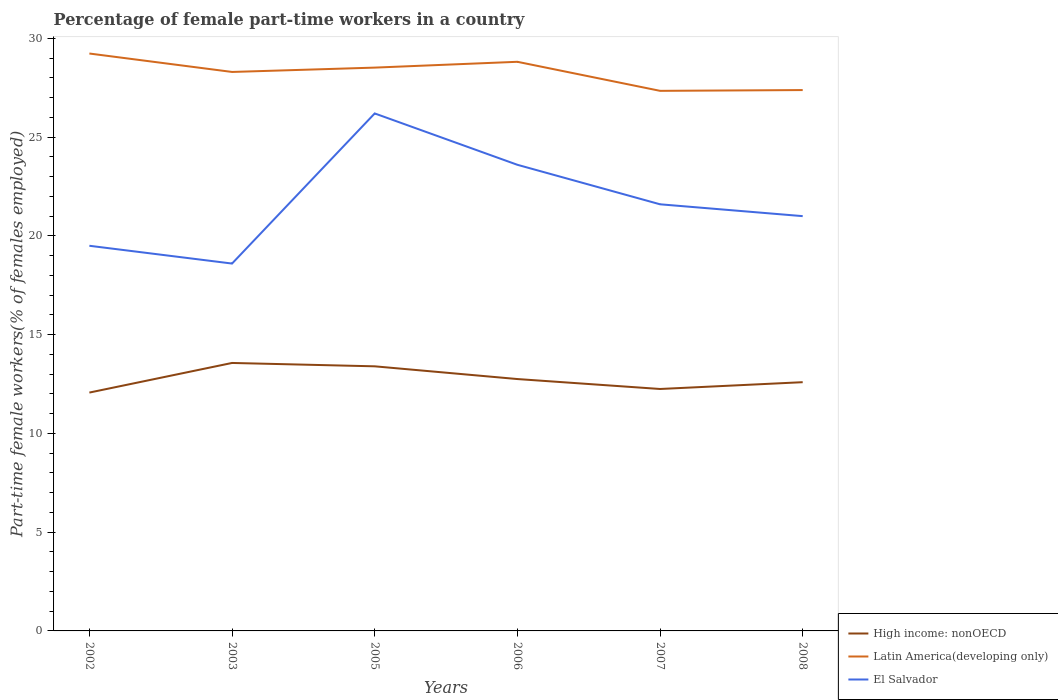How many different coloured lines are there?
Give a very brief answer. 3. Does the line corresponding to High income: nonOECD intersect with the line corresponding to Latin America(developing only)?
Give a very brief answer. No. Across all years, what is the maximum percentage of female part-time workers in High income: nonOECD?
Your response must be concise. 12.07. What is the total percentage of female part-time workers in High income: nonOECD in the graph?
Offer a terse response. 0.64. What is the difference between the highest and the second highest percentage of female part-time workers in High income: nonOECD?
Give a very brief answer. 1.5. How many years are there in the graph?
Give a very brief answer. 6. What is the difference between two consecutive major ticks on the Y-axis?
Your response must be concise. 5. Are the values on the major ticks of Y-axis written in scientific E-notation?
Provide a succinct answer. No. Where does the legend appear in the graph?
Provide a succinct answer. Bottom right. How many legend labels are there?
Your answer should be compact. 3. What is the title of the graph?
Your answer should be compact. Percentage of female part-time workers in a country. Does "Germany" appear as one of the legend labels in the graph?
Your answer should be compact. No. What is the label or title of the X-axis?
Your response must be concise. Years. What is the label or title of the Y-axis?
Your answer should be compact. Part-time female workers(% of females employed). What is the Part-time female workers(% of females employed) of High income: nonOECD in 2002?
Your response must be concise. 12.07. What is the Part-time female workers(% of females employed) in Latin America(developing only) in 2002?
Provide a succinct answer. 29.23. What is the Part-time female workers(% of females employed) in El Salvador in 2002?
Ensure brevity in your answer.  19.5. What is the Part-time female workers(% of females employed) of High income: nonOECD in 2003?
Ensure brevity in your answer.  13.57. What is the Part-time female workers(% of females employed) of Latin America(developing only) in 2003?
Keep it short and to the point. 28.3. What is the Part-time female workers(% of females employed) of El Salvador in 2003?
Your answer should be compact. 18.6. What is the Part-time female workers(% of females employed) of High income: nonOECD in 2005?
Offer a very short reply. 13.4. What is the Part-time female workers(% of females employed) of Latin America(developing only) in 2005?
Offer a terse response. 28.52. What is the Part-time female workers(% of females employed) in El Salvador in 2005?
Ensure brevity in your answer.  26.2. What is the Part-time female workers(% of females employed) in High income: nonOECD in 2006?
Your answer should be very brief. 12.75. What is the Part-time female workers(% of females employed) of Latin America(developing only) in 2006?
Offer a terse response. 28.81. What is the Part-time female workers(% of females employed) in El Salvador in 2006?
Provide a short and direct response. 23.6. What is the Part-time female workers(% of females employed) of High income: nonOECD in 2007?
Make the answer very short. 12.25. What is the Part-time female workers(% of females employed) in Latin America(developing only) in 2007?
Offer a very short reply. 27.34. What is the Part-time female workers(% of females employed) in El Salvador in 2007?
Give a very brief answer. 21.6. What is the Part-time female workers(% of females employed) in High income: nonOECD in 2008?
Provide a short and direct response. 12.59. What is the Part-time female workers(% of females employed) in Latin America(developing only) in 2008?
Your answer should be compact. 27.38. Across all years, what is the maximum Part-time female workers(% of females employed) in High income: nonOECD?
Your answer should be very brief. 13.57. Across all years, what is the maximum Part-time female workers(% of females employed) of Latin America(developing only)?
Ensure brevity in your answer.  29.23. Across all years, what is the maximum Part-time female workers(% of females employed) in El Salvador?
Your response must be concise. 26.2. Across all years, what is the minimum Part-time female workers(% of females employed) in High income: nonOECD?
Make the answer very short. 12.07. Across all years, what is the minimum Part-time female workers(% of females employed) of Latin America(developing only)?
Your answer should be compact. 27.34. Across all years, what is the minimum Part-time female workers(% of females employed) of El Salvador?
Your answer should be compact. 18.6. What is the total Part-time female workers(% of females employed) in High income: nonOECD in the graph?
Ensure brevity in your answer.  76.63. What is the total Part-time female workers(% of females employed) in Latin America(developing only) in the graph?
Your response must be concise. 169.6. What is the total Part-time female workers(% of females employed) in El Salvador in the graph?
Offer a terse response. 130.5. What is the difference between the Part-time female workers(% of females employed) of High income: nonOECD in 2002 and that in 2003?
Ensure brevity in your answer.  -1.5. What is the difference between the Part-time female workers(% of females employed) in Latin America(developing only) in 2002 and that in 2003?
Your answer should be very brief. 0.93. What is the difference between the Part-time female workers(% of females employed) in High income: nonOECD in 2002 and that in 2005?
Offer a terse response. -1.33. What is the difference between the Part-time female workers(% of females employed) in Latin America(developing only) in 2002 and that in 2005?
Give a very brief answer. 0.71. What is the difference between the Part-time female workers(% of females employed) of High income: nonOECD in 2002 and that in 2006?
Keep it short and to the point. -0.68. What is the difference between the Part-time female workers(% of females employed) of Latin America(developing only) in 2002 and that in 2006?
Provide a short and direct response. 0.42. What is the difference between the Part-time female workers(% of females employed) in El Salvador in 2002 and that in 2006?
Offer a terse response. -4.1. What is the difference between the Part-time female workers(% of females employed) in High income: nonOECD in 2002 and that in 2007?
Your response must be concise. -0.18. What is the difference between the Part-time female workers(% of females employed) in Latin America(developing only) in 2002 and that in 2007?
Your answer should be compact. 1.89. What is the difference between the Part-time female workers(% of females employed) in High income: nonOECD in 2002 and that in 2008?
Give a very brief answer. -0.53. What is the difference between the Part-time female workers(% of females employed) of Latin America(developing only) in 2002 and that in 2008?
Provide a short and direct response. 1.85. What is the difference between the Part-time female workers(% of females employed) in El Salvador in 2002 and that in 2008?
Provide a short and direct response. -1.5. What is the difference between the Part-time female workers(% of females employed) in High income: nonOECD in 2003 and that in 2005?
Make the answer very short. 0.17. What is the difference between the Part-time female workers(% of females employed) of Latin America(developing only) in 2003 and that in 2005?
Your response must be concise. -0.22. What is the difference between the Part-time female workers(% of females employed) in El Salvador in 2003 and that in 2005?
Give a very brief answer. -7.6. What is the difference between the Part-time female workers(% of females employed) of High income: nonOECD in 2003 and that in 2006?
Your answer should be compact. 0.81. What is the difference between the Part-time female workers(% of females employed) of Latin America(developing only) in 2003 and that in 2006?
Make the answer very short. -0.51. What is the difference between the Part-time female workers(% of females employed) of El Salvador in 2003 and that in 2006?
Give a very brief answer. -5. What is the difference between the Part-time female workers(% of females employed) of High income: nonOECD in 2003 and that in 2007?
Make the answer very short. 1.32. What is the difference between the Part-time female workers(% of females employed) of Latin America(developing only) in 2003 and that in 2007?
Your answer should be compact. 0.96. What is the difference between the Part-time female workers(% of females employed) in High income: nonOECD in 2003 and that in 2008?
Provide a short and direct response. 0.97. What is the difference between the Part-time female workers(% of females employed) of Latin America(developing only) in 2003 and that in 2008?
Make the answer very short. 0.92. What is the difference between the Part-time female workers(% of females employed) in High income: nonOECD in 2005 and that in 2006?
Provide a short and direct response. 0.64. What is the difference between the Part-time female workers(% of females employed) of Latin America(developing only) in 2005 and that in 2006?
Offer a terse response. -0.29. What is the difference between the Part-time female workers(% of females employed) in High income: nonOECD in 2005 and that in 2007?
Offer a very short reply. 1.15. What is the difference between the Part-time female workers(% of females employed) in Latin America(developing only) in 2005 and that in 2007?
Provide a succinct answer. 1.18. What is the difference between the Part-time female workers(% of females employed) of El Salvador in 2005 and that in 2007?
Keep it short and to the point. 4.6. What is the difference between the Part-time female workers(% of females employed) of High income: nonOECD in 2005 and that in 2008?
Provide a short and direct response. 0.8. What is the difference between the Part-time female workers(% of females employed) in Latin America(developing only) in 2005 and that in 2008?
Provide a succinct answer. 1.14. What is the difference between the Part-time female workers(% of females employed) in El Salvador in 2005 and that in 2008?
Your response must be concise. 5.2. What is the difference between the Part-time female workers(% of females employed) in High income: nonOECD in 2006 and that in 2007?
Your answer should be compact. 0.5. What is the difference between the Part-time female workers(% of females employed) in Latin America(developing only) in 2006 and that in 2007?
Offer a terse response. 1.47. What is the difference between the Part-time female workers(% of females employed) in High income: nonOECD in 2006 and that in 2008?
Your answer should be compact. 0.16. What is the difference between the Part-time female workers(% of females employed) in Latin America(developing only) in 2006 and that in 2008?
Your response must be concise. 1.43. What is the difference between the Part-time female workers(% of females employed) in High income: nonOECD in 2007 and that in 2008?
Keep it short and to the point. -0.34. What is the difference between the Part-time female workers(% of females employed) of Latin America(developing only) in 2007 and that in 2008?
Ensure brevity in your answer.  -0.04. What is the difference between the Part-time female workers(% of females employed) of High income: nonOECD in 2002 and the Part-time female workers(% of females employed) of Latin America(developing only) in 2003?
Your response must be concise. -16.23. What is the difference between the Part-time female workers(% of females employed) in High income: nonOECD in 2002 and the Part-time female workers(% of females employed) in El Salvador in 2003?
Keep it short and to the point. -6.53. What is the difference between the Part-time female workers(% of females employed) in Latin America(developing only) in 2002 and the Part-time female workers(% of females employed) in El Salvador in 2003?
Give a very brief answer. 10.63. What is the difference between the Part-time female workers(% of females employed) of High income: nonOECD in 2002 and the Part-time female workers(% of females employed) of Latin America(developing only) in 2005?
Make the answer very short. -16.45. What is the difference between the Part-time female workers(% of females employed) of High income: nonOECD in 2002 and the Part-time female workers(% of females employed) of El Salvador in 2005?
Provide a succinct answer. -14.13. What is the difference between the Part-time female workers(% of females employed) in Latin America(developing only) in 2002 and the Part-time female workers(% of females employed) in El Salvador in 2005?
Give a very brief answer. 3.03. What is the difference between the Part-time female workers(% of females employed) in High income: nonOECD in 2002 and the Part-time female workers(% of females employed) in Latin America(developing only) in 2006?
Provide a short and direct response. -16.75. What is the difference between the Part-time female workers(% of females employed) in High income: nonOECD in 2002 and the Part-time female workers(% of females employed) in El Salvador in 2006?
Offer a very short reply. -11.53. What is the difference between the Part-time female workers(% of females employed) of Latin America(developing only) in 2002 and the Part-time female workers(% of females employed) of El Salvador in 2006?
Make the answer very short. 5.63. What is the difference between the Part-time female workers(% of females employed) of High income: nonOECD in 2002 and the Part-time female workers(% of females employed) of Latin America(developing only) in 2007?
Keep it short and to the point. -15.28. What is the difference between the Part-time female workers(% of females employed) in High income: nonOECD in 2002 and the Part-time female workers(% of females employed) in El Salvador in 2007?
Your response must be concise. -9.53. What is the difference between the Part-time female workers(% of females employed) of Latin America(developing only) in 2002 and the Part-time female workers(% of females employed) of El Salvador in 2007?
Your response must be concise. 7.63. What is the difference between the Part-time female workers(% of females employed) of High income: nonOECD in 2002 and the Part-time female workers(% of females employed) of Latin America(developing only) in 2008?
Your answer should be compact. -15.32. What is the difference between the Part-time female workers(% of females employed) of High income: nonOECD in 2002 and the Part-time female workers(% of females employed) of El Salvador in 2008?
Offer a terse response. -8.93. What is the difference between the Part-time female workers(% of females employed) in Latin America(developing only) in 2002 and the Part-time female workers(% of females employed) in El Salvador in 2008?
Make the answer very short. 8.23. What is the difference between the Part-time female workers(% of females employed) of High income: nonOECD in 2003 and the Part-time female workers(% of females employed) of Latin America(developing only) in 2005?
Ensure brevity in your answer.  -14.95. What is the difference between the Part-time female workers(% of females employed) of High income: nonOECD in 2003 and the Part-time female workers(% of females employed) of El Salvador in 2005?
Your answer should be compact. -12.63. What is the difference between the Part-time female workers(% of females employed) in Latin America(developing only) in 2003 and the Part-time female workers(% of females employed) in El Salvador in 2005?
Your answer should be very brief. 2.1. What is the difference between the Part-time female workers(% of females employed) in High income: nonOECD in 2003 and the Part-time female workers(% of females employed) in Latin America(developing only) in 2006?
Ensure brevity in your answer.  -15.25. What is the difference between the Part-time female workers(% of females employed) of High income: nonOECD in 2003 and the Part-time female workers(% of females employed) of El Salvador in 2006?
Give a very brief answer. -10.03. What is the difference between the Part-time female workers(% of females employed) of Latin America(developing only) in 2003 and the Part-time female workers(% of females employed) of El Salvador in 2006?
Give a very brief answer. 4.7. What is the difference between the Part-time female workers(% of females employed) in High income: nonOECD in 2003 and the Part-time female workers(% of females employed) in Latin America(developing only) in 2007?
Your answer should be compact. -13.78. What is the difference between the Part-time female workers(% of females employed) in High income: nonOECD in 2003 and the Part-time female workers(% of females employed) in El Salvador in 2007?
Give a very brief answer. -8.03. What is the difference between the Part-time female workers(% of females employed) of Latin America(developing only) in 2003 and the Part-time female workers(% of females employed) of El Salvador in 2007?
Your answer should be compact. 6.7. What is the difference between the Part-time female workers(% of females employed) of High income: nonOECD in 2003 and the Part-time female workers(% of females employed) of Latin America(developing only) in 2008?
Make the answer very short. -13.82. What is the difference between the Part-time female workers(% of females employed) in High income: nonOECD in 2003 and the Part-time female workers(% of females employed) in El Salvador in 2008?
Your answer should be compact. -7.43. What is the difference between the Part-time female workers(% of females employed) of Latin America(developing only) in 2003 and the Part-time female workers(% of females employed) of El Salvador in 2008?
Offer a terse response. 7.3. What is the difference between the Part-time female workers(% of females employed) of High income: nonOECD in 2005 and the Part-time female workers(% of females employed) of Latin America(developing only) in 2006?
Keep it short and to the point. -15.42. What is the difference between the Part-time female workers(% of females employed) in High income: nonOECD in 2005 and the Part-time female workers(% of females employed) in El Salvador in 2006?
Give a very brief answer. -10.2. What is the difference between the Part-time female workers(% of females employed) of Latin America(developing only) in 2005 and the Part-time female workers(% of females employed) of El Salvador in 2006?
Your response must be concise. 4.92. What is the difference between the Part-time female workers(% of females employed) of High income: nonOECD in 2005 and the Part-time female workers(% of females employed) of Latin America(developing only) in 2007?
Ensure brevity in your answer.  -13.95. What is the difference between the Part-time female workers(% of females employed) in High income: nonOECD in 2005 and the Part-time female workers(% of females employed) in El Salvador in 2007?
Offer a very short reply. -8.2. What is the difference between the Part-time female workers(% of females employed) in Latin America(developing only) in 2005 and the Part-time female workers(% of females employed) in El Salvador in 2007?
Ensure brevity in your answer.  6.92. What is the difference between the Part-time female workers(% of females employed) in High income: nonOECD in 2005 and the Part-time female workers(% of females employed) in Latin America(developing only) in 2008?
Your answer should be very brief. -13.99. What is the difference between the Part-time female workers(% of females employed) in High income: nonOECD in 2005 and the Part-time female workers(% of females employed) in El Salvador in 2008?
Give a very brief answer. -7.6. What is the difference between the Part-time female workers(% of females employed) in Latin America(developing only) in 2005 and the Part-time female workers(% of females employed) in El Salvador in 2008?
Ensure brevity in your answer.  7.52. What is the difference between the Part-time female workers(% of females employed) of High income: nonOECD in 2006 and the Part-time female workers(% of females employed) of Latin America(developing only) in 2007?
Offer a terse response. -14.59. What is the difference between the Part-time female workers(% of females employed) of High income: nonOECD in 2006 and the Part-time female workers(% of females employed) of El Salvador in 2007?
Give a very brief answer. -8.85. What is the difference between the Part-time female workers(% of females employed) of Latin America(developing only) in 2006 and the Part-time female workers(% of females employed) of El Salvador in 2007?
Provide a succinct answer. 7.21. What is the difference between the Part-time female workers(% of females employed) of High income: nonOECD in 2006 and the Part-time female workers(% of females employed) of Latin America(developing only) in 2008?
Your response must be concise. -14.63. What is the difference between the Part-time female workers(% of females employed) in High income: nonOECD in 2006 and the Part-time female workers(% of females employed) in El Salvador in 2008?
Give a very brief answer. -8.25. What is the difference between the Part-time female workers(% of females employed) in Latin America(developing only) in 2006 and the Part-time female workers(% of females employed) in El Salvador in 2008?
Your answer should be very brief. 7.81. What is the difference between the Part-time female workers(% of females employed) of High income: nonOECD in 2007 and the Part-time female workers(% of females employed) of Latin America(developing only) in 2008?
Provide a succinct answer. -15.13. What is the difference between the Part-time female workers(% of females employed) of High income: nonOECD in 2007 and the Part-time female workers(% of females employed) of El Salvador in 2008?
Your response must be concise. -8.75. What is the difference between the Part-time female workers(% of females employed) in Latin America(developing only) in 2007 and the Part-time female workers(% of females employed) in El Salvador in 2008?
Provide a short and direct response. 6.34. What is the average Part-time female workers(% of females employed) of High income: nonOECD per year?
Your answer should be very brief. 12.77. What is the average Part-time female workers(% of females employed) in Latin America(developing only) per year?
Provide a short and direct response. 28.27. What is the average Part-time female workers(% of females employed) of El Salvador per year?
Make the answer very short. 21.75. In the year 2002, what is the difference between the Part-time female workers(% of females employed) in High income: nonOECD and Part-time female workers(% of females employed) in Latin America(developing only)?
Your answer should be very brief. -17.17. In the year 2002, what is the difference between the Part-time female workers(% of females employed) of High income: nonOECD and Part-time female workers(% of females employed) of El Salvador?
Your answer should be very brief. -7.43. In the year 2002, what is the difference between the Part-time female workers(% of females employed) in Latin America(developing only) and Part-time female workers(% of females employed) in El Salvador?
Offer a terse response. 9.73. In the year 2003, what is the difference between the Part-time female workers(% of females employed) in High income: nonOECD and Part-time female workers(% of females employed) in Latin America(developing only)?
Offer a very short reply. -14.73. In the year 2003, what is the difference between the Part-time female workers(% of females employed) in High income: nonOECD and Part-time female workers(% of females employed) in El Salvador?
Offer a very short reply. -5.03. In the year 2003, what is the difference between the Part-time female workers(% of females employed) in Latin America(developing only) and Part-time female workers(% of females employed) in El Salvador?
Your answer should be compact. 9.7. In the year 2005, what is the difference between the Part-time female workers(% of females employed) in High income: nonOECD and Part-time female workers(% of females employed) in Latin America(developing only)?
Offer a very short reply. -15.12. In the year 2005, what is the difference between the Part-time female workers(% of females employed) in High income: nonOECD and Part-time female workers(% of females employed) in El Salvador?
Offer a terse response. -12.8. In the year 2005, what is the difference between the Part-time female workers(% of females employed) of Latin America(developing only) and Part-time female workers(% of females employed) of El Salvador?
Make the answer very short. 2.32. In the year 2006, what is the difference between the Part-time female workers(% of females employed) in High income: nonOECD and Part-time female workers(% of females employed) in Latin America(developing only)?
Provide a short and direct response. -16.06. In the year 2006, what is the difference between the Part-time female workers(% of females employed) of High income: nonOECD and Part-time female workers(% of females employed) of El Salvador?
Your answer should be compact. -10.85. In the year 2006, what is the difference between the Part-time female workers(% of females employed) in Latin America(developing only) and Part-time female workers(% of females employed) in El Salvador?
Offer a terse response. 5.21. In the year 2007, what is the difference between the Part-time female workers(% of females employed) in High income: nonOECD and Part-time female workers(% of females employed) in Latin America(developing only)?
Give a very brief answer. -15.1. In the year 2007, what is the difference between the Part-time female workers(% of females employed) of High income: nonOECD and Part-time female workers(% of females employed) of El Salvador?
Keep it short and to the point. -9.35. In the year 2007, what is the difference between the Part-time female workers(% of females employed) in Latin America(developing only) and Part-time female workers(% of females employed) in El Salvador?
Offer a terse response. 5.74. In the year 2008, what is the difference between the Part-time female workers(% of females employed) in High income: nonOECD and Part-time female workers(% of females employed) in Latin America(developing only)?
Your answer should be very brief. -14.79. In the year 2008, what is the difference between the Part-time female workers(% of females employed) in High income: nonOECD and Part-time female workers(% of females employed) in El Salvador?
Your answer should be very brief. -8.41. In the year 2008, what is the difference between the Part-time female workers(% of females employed) in Latin America(developing only) and Part-time female workers(% of females employed) in El Salvador?
Make the answer very short. 6.38. What is the ratio of the Part-time female workers(% of females employed) of High income: nonOECD in 2002 to that in 2003?
Give a very brief answer. 0.89. What is the ratio of the Part-time female workers(% of females employed) in Latin America(developing only) in 2002 to that in 2003?
Offer a very short reply. 1.03. What is the ratio of the Part-time female workers(% of females employed) of El Salvador in 2002 to that in 2003?
Your answer should be very brief. 1.05. What is the ratio of the Part-time female workers(% of females employed) of High income: nonOECD in 2002 to that in 2005?
Make the answer very short. 0.9. What is the ratio of the Part-time female workers(% of females employed) of Latin America(developing only) in 2002 to that in 2005?
Ensure brevity in your answer.  1.02. What is the ratio of the Part-time female workers(% of females employed) in El Salvador in 2002 to that in 2005?
Your answer should be very brief. 0.74. What is the ratio of the Part-time female workers(% of females employed) of High income: nonOECD in 2002 to that in 2006?
Offer a very short reply. 0.95. What is the ratio of the Part-time female workers(% of females employed) of Latin America(developing only) in 2002 to that in 2006?
Your answer should be very brief. 1.01. What is the ratio of the Part-time female workers(% of females employed) in El Salvador in 2002 to that in 2006?
Make the answer very short. 0.83. What is the ratio of the Part-time female workers(% of females employed) in High income: nonOECD in 2002 to that in 2007?
Give a very brief answer. 0.99. What is the ratio of the Part-time female workers(% of females employed) of Latin America(developing only) in 2002 to that in 2007?
Offer a very short reply. 1.07. What is the ratio of the Part-time female workers(% of females employed) of El Salvador in 2002 to that in 2007?
Offer a very short reply. 0.9. What is the ratio of the Part-time female workers(% of females employed) in Latin America(developing only) in 2002 to that in 2008?
Give a very brief answer. 1.07. What is the ratio of the Part-time female workers(% of females employed) in El Salvador in 2002 to that in 2008?
Your answer should be compact. 0.93. What is the ratio of the Part-time female workers(% of females employed) of High income: nonOECD in 2003 to that in 2005?
Your answer should be very brief. 1.01. What is the ratio of the Part-time female workers(% of females employed) of Latin America(developing only) in 2003 to that in 2005?
Offer a very short reply. 0.99. What is the ratio of the Part-time female workers(% of females employed) of El Salvador in 2003 to that in 2005?
Offer a terse response. 0.71. What is the ratio of the Part-time female workers(% of females employed) of High income: nonOECD in 2003 to that in 2006?
Your answer should be compact. 1.06. What is the ratio of the Part-time female workers(% of females employed) in Latin America(developing only) in 2003 to that in 2006?
Offer a very short reply. 0.98. What is the ratio of the Part-time female workers(% of females employed) of El Salvador in 2003 to that in 2006?
Your answer should be very brief. 0.79. What is the ratio of the Part-time female workers(% of females employed) of High income: nonOECD in 2003 to that in 2007?
Offer a terse response. 1.11. What is the ratio of the Part-time female workers(% of females employed) of Latin America(developing only) in 2003 to that in 2007?
Keep it short and to the point. 1.03. What is the ratio of the Part-time female workers(% of females employed) in El Salvador in 2003 to that in 2007?
Offer a very short reply. 0.86. What is the ratio of the Part-time female workers(% of females employed) of High income: nonOECD in 2003 to that in 2008?
Provide a succinct answer. 1.08. What is the ratio of the Part-time female workers(% of females employed) of Latin America(developing only) in 2003 to that in 2008?
Provide a short and direct response. 1.03. What is the ratio of the Part-time female workers(% of females employed) in El Salvador in 2003 to that in 2008?
Your answer should be compact. 0.89. What is the ratio of the Part-time female workers(% of females employed) in High income: nonOECD in 2005 to that in 2006?
Offer a very short reply. 1.05. What is the ratio of the Part-time female workers(% of females employed) in El Salvador in 2005 to that in 2006?
Offer a terse response. 1.11. What is the ratio of the Part-time female workers(% of females employed) in High income: nonOECD in 2005 to that in 2007?
Offer a terse response. 1.09. What is the ratio of the Part-time female workers(% of females employed) of Latin America(developing only) in 2005 to that in 2007?
Give a very brief answer. 1.04. What is the ratio of the Part-time female workers(% of females employed) in El Salvador in 2005 to that in 2007?
Offer a terse response. 1.21. What is the ratio of the Part-time female workers(% of females employed) in High income: nonOECD in 2005 to that in 2008?
Keep it short and to the point. 1.06. What is the ratio of the Part-time female workers(% of females employed) in Latin America(developing only) in 2005 to that in 2008?
Offer a very short reply. 1.04. What is the ratio of the Part-time female workers(% of females employed) of El Salvador in 2005 to that in 2008?
Your response must be concise. 1.25. What is the ratio of the Part-time female workers(% of females employed) of High income: nonOECD in 2006 to that in 2007?
Provide a succinct answer. 1.04. What is the ratio of the Part-time female workers(% of females employed) in Latin America(developing only) in 2006 to that in 2007?
Make the answer very short. 1.05. What is the ratio of the Part-time female workers(% of females employed) of El Salvador in 2006 to that in 2007?
Provide a short and direct response. 1.09. What is the ratio of the Part-time female workers(% of females employed) of High income: nonOECD in 2006 to that in 2008?
Give a very brief answer. 1.01. What is the ratio of the Part-time female workers(% of females employed) in Latin America(developing only) in 2006 to that in 2008?
Give a very brief answer. 1.05. What is the ratio of the Part-time female workers(% of females employed) of El Salvador in 2006 to that in 2008?
Give a very brief answer. 1.12. What is the ratio of the Part-time female workers(% of females employed) of High income: nonOECD in 2007 to that in 2008?
Your response must be concise. 0.97. What is the ratio of the Part-time female workers(% of females employed) in El Salvador in 2007 to that in 2008?
Your answer should be very brief. 1.03. What is the difference between the highest and the second highest Part-time female workers(% of females employed) of High income: nonOECD?
Keep it short and to the point. 0.17. What is the difference between the highest and the second highest Part-time female workers(% of females employed) of Latin America(developing only)?
Make the answer very short. 0.42. What is the difference between the highest and the lowest Part-time female workers(% of females employed) in High income: nonOECD?
Your answer should be compact. 1.5. What is the difference between the highest and the lowest Part-time female workers(% of females employed) in Latin America(developing only)?
Your answer should be very brief. 1.89. What is the difference between the highest and the lowest Part-time female workers(% of females employed) of El Salvador?
Ensure brevity in your answer.  7.6. 